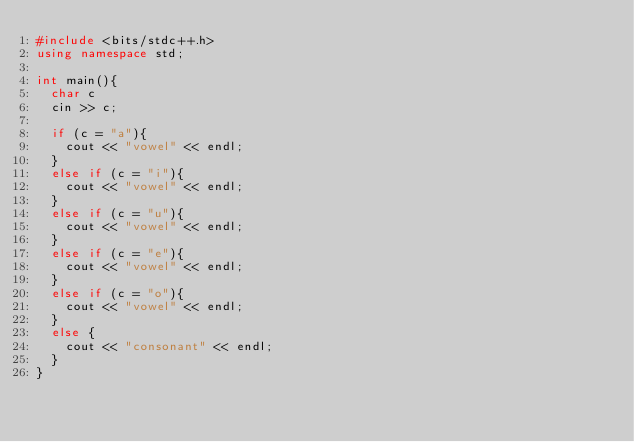<code> <loc_0><loc_0><loc_500><loc_500><_C++_>#include <bits/stdc++.h>
using namespace std;

int main(){
  char c 
  cin >> c;
  
  if (c = "a"){
    cout << "vowel" << endl;
  }
  else if (c = "i"){
    cout << "vowel" << endl;
  }
  else if (c = "u"){
    cout << "vowel" << endl;
  }
  else if (c = "e"){
    cout << "vowel" << endl;
  }
  else if (c = "o"){
    cout << "vowel" << endl;
  }
  else {
    cout << "consonant" << endl;
  }
}</code> 